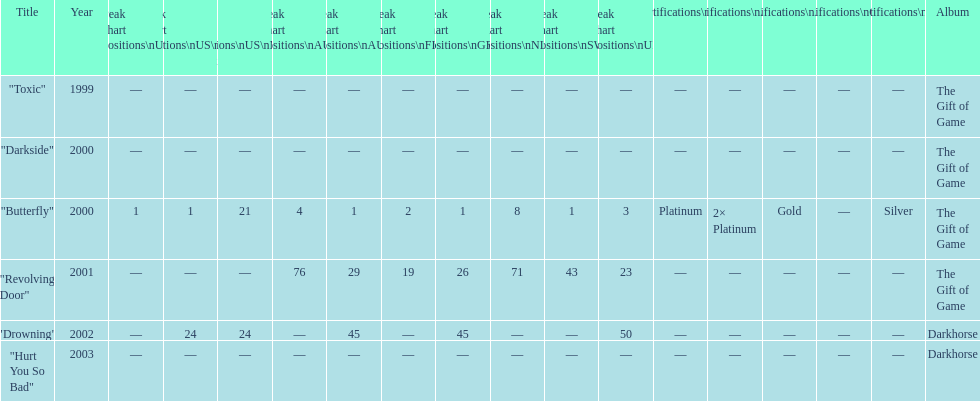By how many chart positions higher did "revolving door" peak in the uk compared to the peak position of "drowning" in the uk? 27. 